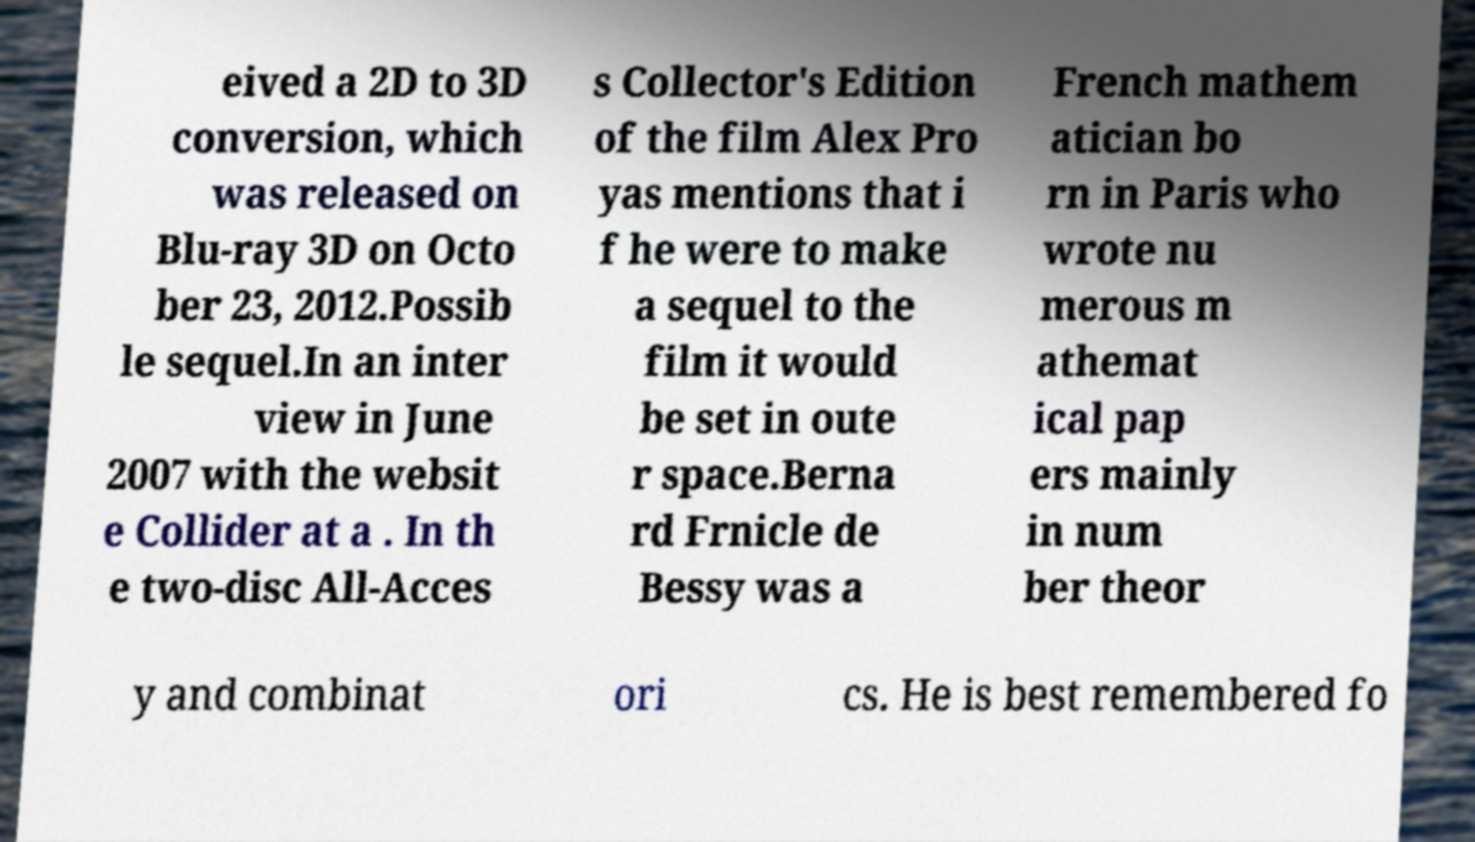Could you assist in decoding the text presented in this image and type it out clearly? eived a 2D to 3D conversion, which was released on Blu-ray 3D on Octo ber 23, 2012.Possib le sequel.In an inter view in June 2007 with the websit e Collider at a . In th e two-disc All-Acces s Collector's Edition of the film Alex Pro yas mentions that i f he were to make a sequel to the film it would be set in oute r space.Berna rd Frnicle de Bessy was a French mathem atician bo rn in Paris who wrote nu merous m athemat ical pap ers mainly in num ber theor y and combinat ori cs. He is best remembered fo 